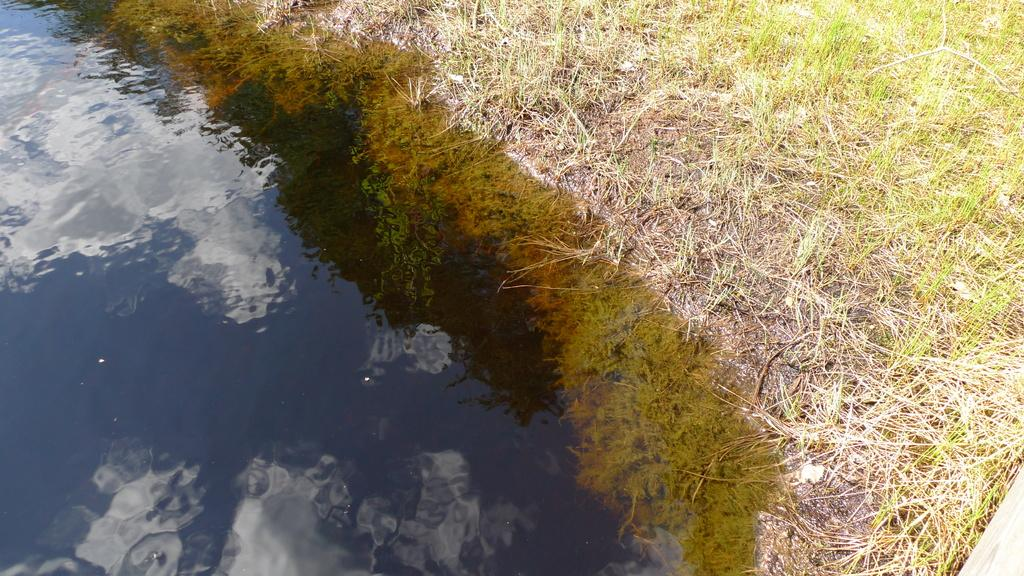What is present in the image that is not solid? There is water in the image. What type of living organisms can be seen in the image? There are plants in the image. What can be seen in the water's reflection? The reflection of clouds is visible in the water. What type of star can be seen shining brightly in the image? There is no star visible in the image; it features water, plants, and the reflection of clouds. 